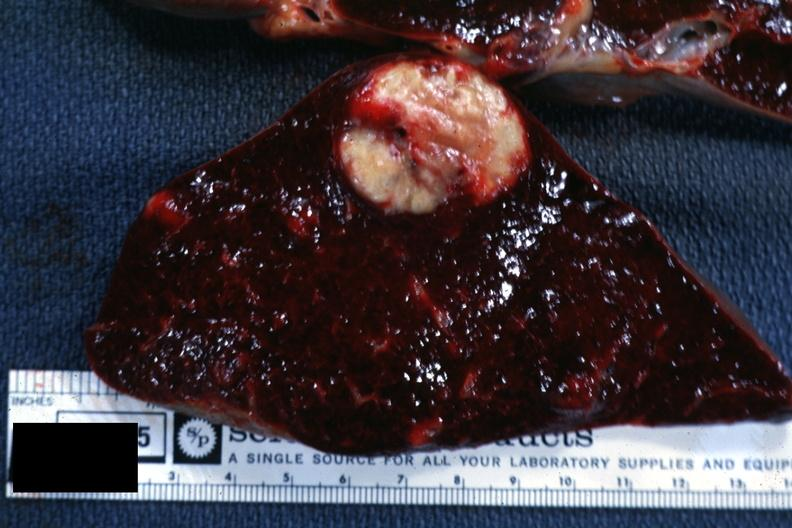what is present?
Answer the question using a single word or phrase. Hematologic 